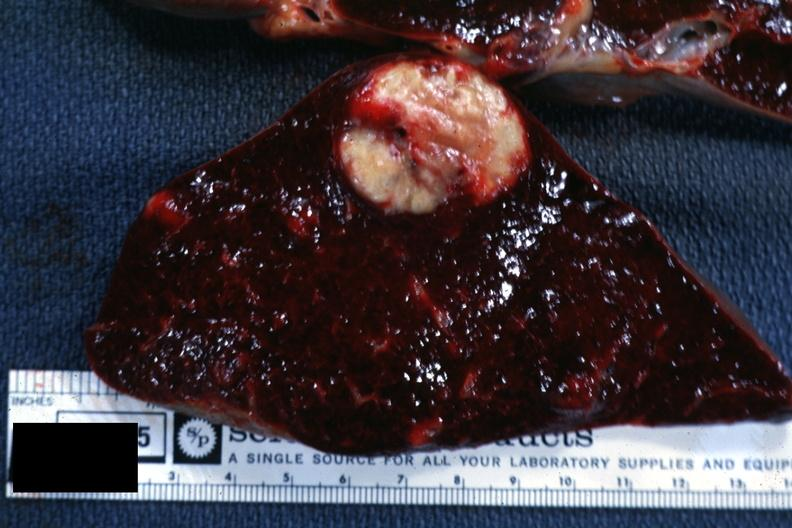what is present?
Answer the question using a single word or phrase. Hematologic 